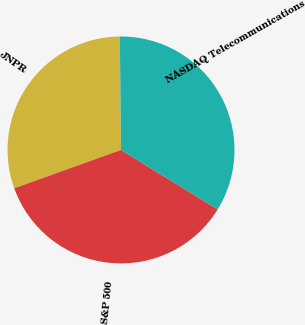<chart> <loc_0><loc_0><loc_500><loc_500><pie_chart><fcel>JNPR<fcel>S&P 500<fcel>NASDAQ Telecommunications<nl><fcel>30.31%<fcel>35.74%<fcel>33.95%<nl></chart> 